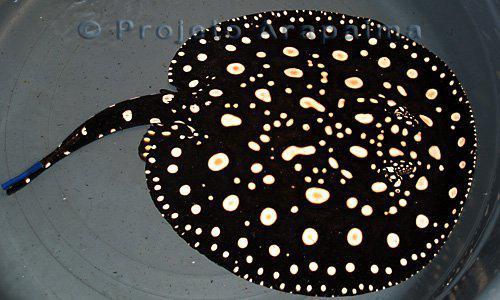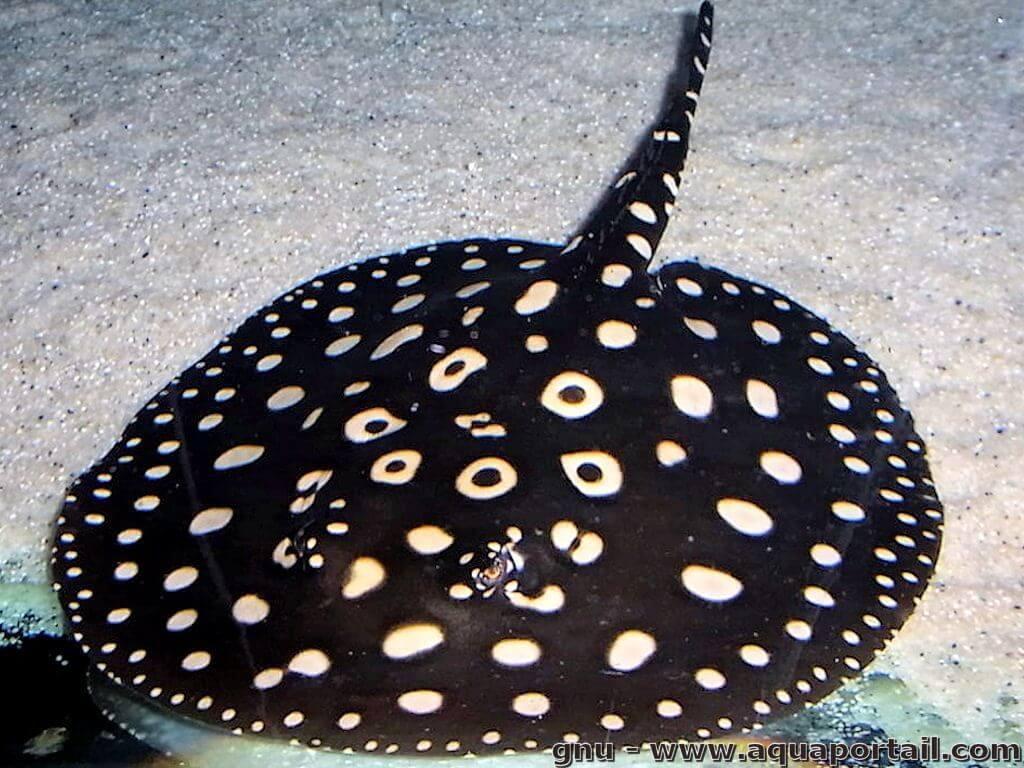The first image is the image on the left, the second image is the image on the right. Examine the images to the left and right. Is the description "Both stingrays have white spots and their tails are pointed in different directions." accurate? Answer yes or no. Yes. 